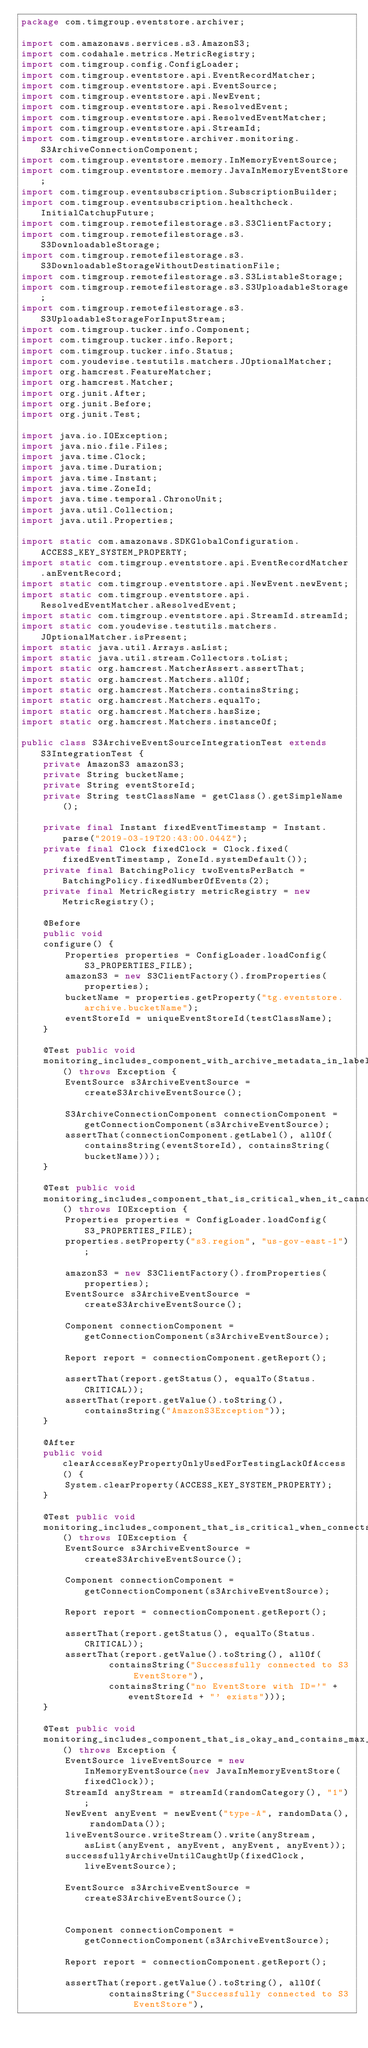<code> <loc_0><loc_0><loc_500><loc_500><_Java_>package com.timgroup.eventstore.archiver;

import com.amazonaws.services.s3.AmazonS3;
import com.codahale.metrics.MetricRegistry;
import com.timgroup.config.ConfigLoader;
import com.timgroup.eventstore.api.EventRecordMatcher;
import com.timgroup.eventstore.api.EventSource;
import com.timgroup.eventstore.api.NewEvent;
import com.timgroup.eventstore.api.ResolvedEvent;
import com.timgroup.eventstore.api.ResolvedEventMatcher;
import com.timgroup.eventstore.api.StreamId;
import com.timgroup.eventstore.archiver.monitoring.S3ArchiveConnectionComponent;
import com.timgroup.eventstore.memory.InMemoryEventSource;
import com.timgroup.eventstore.memory.JavaInMemoryEventStore;
import com.timgroup.eventsubscription.SubscriptionBuilder;
import com.timgroup.eventsubscription.healthcheck.InitialCatchupFuture;
import com.timgroup.remotefilestorage.s3.S3ClientFactory;
import com.timgroup.remotefilestorage.s3.S3DownloadableStorage;
import com.timgroup.remotefilestorage.s3.S3DownloadableStorageWithoutDestinationFile;
import com.timgroup.remotefilestorage.s3.S3ListableStorage;
import com.timgroup.remotefilestorage.s3.S3UploadableStorage;
import com.timgroup.remotefilestorage.s3.S3UploadableStorageForInputStream;
import com.timgroup.tucker.info.Component;
import com.timgroup.tucker.info.Report;
import com.timgroup.tucker.info.Status;
import com.youdevise.testutils.matchers.JOptionalMatcher;
import org.hamcrest.FeatureMatcher;
import org.hamcrest.Matcher;
import org.junit.After;
import org.junit.Before;
import org.junit.Test;

import java.io.IOException;
import java.nio.file.Files;
import java.time.Clock;
import java.time.Duration;
import java.time.Instant;
import java.time.ZoneId;
import java.time.temporal.ChronoUnit;
import java.util.Collection;
import java.util.Properties;

import static com.amazonaws.SDKGlobalConfiguration.ACCESS_KEY_SYSTEM_PROPERTY;
import static com.timgroup.eventstore.api.EventRecordMatcher.anEventRecord;
import static com.timgroup.eventstore.api.NewEvent.newEvent;
import static com.timgroup.eventstore.api.ResolvedEventMatcher.aResolvedEvent;
import static com.timgroup.eventstore.api.StreamId.streamId;
import static com.youdevise.testutils.matchers.JOptionalMatcher.isPresent;
import static java.util.Arrays.asList;
import static java.util.stream.Collectors.toList;
import static org.hamcrest.MatcherAssert.assertThat;
import static org.hamcrest.Matchers.allOf;
import static org.hamcrest.Matchers.containsString;
import static org.hamcrest.Matchers.equalTo;
import static org.hamcrest.Matchers.hasSize;
import static org.hamcrest.Matchers.instanceOf;

public class S3ArchiveEventSourceIntegrationTest extends S3IntegrationTest {
    private AmazonS3 amazonS3;
    private String bucketName;
    private String eventStoreId;
    private String testClassName = getClass().getSimpleName();

    private final Instant fixedEventTimestamp = Instant.parse("2019-03-19T20:43:00.044Z");
    private final Clock fixedClock = Clock.fixed(fixedEventTimestamp, ZoneId.systemDefault());
    private final BatchingPolicy twoEventsPerBatch =  BatchingPolicy.fixedNumberOfEvents(2);
    private final MetricRegistry metricRegistry = new MetricRegistry();

    @Before
    public void
    configure() {
        Properties properties = ConfigLoader.loadConfig(S3_PROPERTIES_FILE);
        amazonS3 = new S3ClientFactory().fromProperties(properties);
        bucketName = properties.getProperty("tg.eventstore.archive.bucketName");
        eventStoreId = uniqueEventStoreId(testClassName);
    }

    @Test public void
    monitoring_includes_component_with_archive_metadata_in_label() throws Exception {
        EventSource s3ArchiveEventSource = createS3ArchiveEventSource();

        S3ArchiveConnectionComponent connectionComponent = getConnectionComponent(s3ArchiveEventSource);
        assertThat(connectionComponent.getLabel(), allOf(containsString(eventStoreId), containsString(bucketName)));
    }

    @Test public void
    monitoring_includes_component_that_is_critical_when_it_cannot_connect_to_s3_archive() throws IOException {
        Properties properties = ConfigLoader.loadConfig(S3_PROPERTIES_FILE);
        properties.setProperty("s3.region", "us-gov-east-1");

        amazonS3 = new S3ClientFactory().fromProperties(properties);
        EventSource s3ArchiveEventSource = createS3ArchiveEventSource();

        Component connectionComponent = getConnectionComponent(s3ArchiveEventSource);

        Report report = connectionComponent.getReport();

        assertThat(report.getStatus(), equalTo(Status.CRITICAL));
        assertThat(report.getValue().toString(), containsString("AmazonS3Exception"));
    }

    @After
    public void clearAccessKeyPropertyOnlyUsedForTestingLackOfAccess() {
        System.clearProperty(ACCESS_KEY_SYSTEM_PROPERTY);
    }

    @Test public void
    monitoring_includes_component_that_is_critical_when_connects_to_s3_archive_but_event_store_does_not_exist() throws IOException {
        EventSource s3ArchiveEventSource = createS3ArchiveEventSource();

        Component connectionComponent = getConnectionComponent(s3ArchiveEventSource);

        Report report = connectionComponent.getReport();

        assertThat(report.getStatus(), equalTo(Status.CRITICAL));
        assertThat(report.getValue().toString(), allOf(
                containsString("Successfully connected to S3 EventStore"),
                containsString("no EventStore with ID='" + eventStoreId + "' exists")));
    }

    @Test public void
    monitoring_includes_component_that_is_okay_and_contains_max_position_when_it_can_connect_to_archive() throws Exception {
        EventSource liveEventSource = new InMemoryEventSource(new JavaInMemoryEventStore(fixedClock));
        StreamId anyStream = streamId(randomCategory(), "1");
        NewEvent anyEvent = newEvent("type-A", randomData(), randomData());
        liveEventSource.writeStream().write(anyStream, asList(anyEvent, anyEvent, anyEvent, anyEvent));
        successfullyArchiveUntilCaughtUp(fixedClock, liveEventSource);

        EventSource s3ArchiveEventSource = createS3ArchiveEventSource();


        Component connectionComponent = getConnectionComponent(s3ArchiveEventSource);

        Report report = connectionComponent.getReport();

        assertThat(report.getValue().toString(), allOf(
                containsString("Successfully connected to S3 EventStore"),</code> 